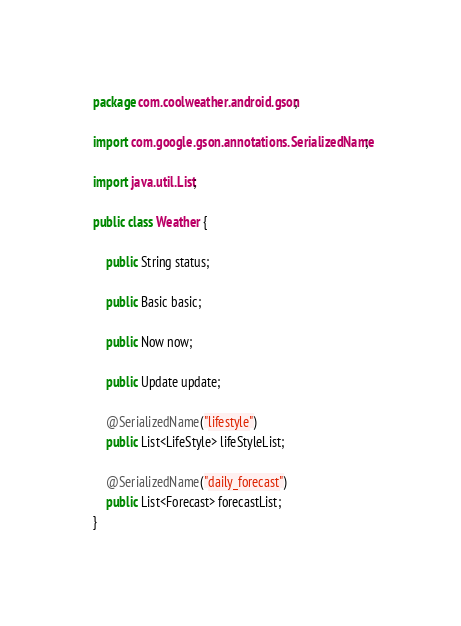<code> <loc_0><loc_0><loc_500><loc_500><_Java_>package com.coolweather.android.gson;

import com.google.gson.annotations.SerializedName;

import java.util.List;

public class Weather {

    public String status;

    public Basic basic;

    public Now now;

    public Update update;

    @SerializedName("lifestyle")
    public List<LifeStyle> lifeStyleList;

    @SerializedName("daily_forecast")
    public List<Forecast> forecastList;
}
</code> 